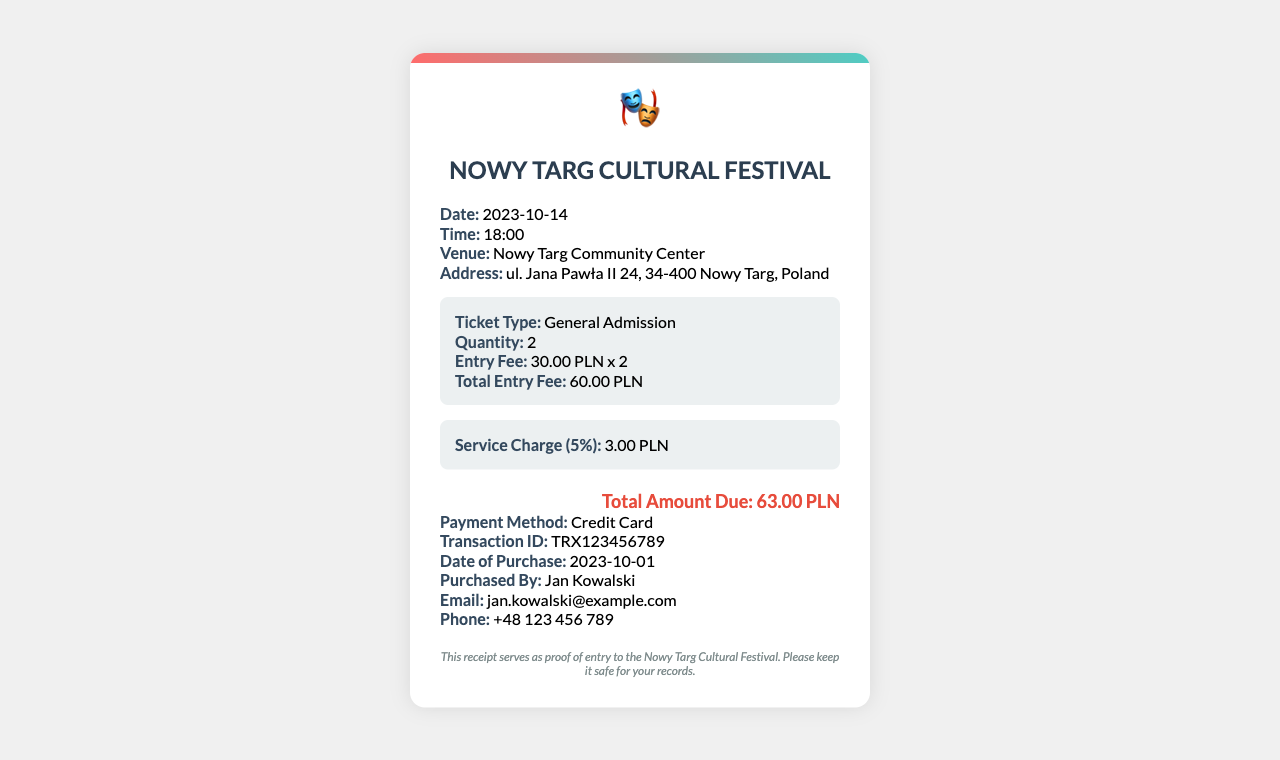What is the date of the event? The date of the event is specifically mentioned in the receipt under the information section.
Answer: 2023-10-14 How much is the entry fee per ticket? The entry fee per ticket is detailed in the ticket details section.
Answer: 30.00 PLN What is the total amount due? The total amount due is clearly stated in the total section of the receipt.
Answer: 63.00 PLN Who is the ticket purchased by? The purchaser's name is listed in the payment information section of the receipt.
Answer: Jan Kowalski What is the service charge percentage? The service charge percentage is inferred from the charges section that mentions a specific amount.
Answer: 5% How many tickets were purchased? The quantity of tickets is indicated in the ticket details section of the receipt.
Answer: 2 What method of payment was used? The method of payment is specified in the payment information section of the receipt.
Answer: Credit Card What is the transaction ID? The transaction ID is explicitly stated in the payment information section.
Answer: TRX123456789 What is the address of the venue? The address of the venue is found in the information section of the receipt.
Answer: ul. Jana Pawła II 24, 34-400 Nowy Targ, Poland 